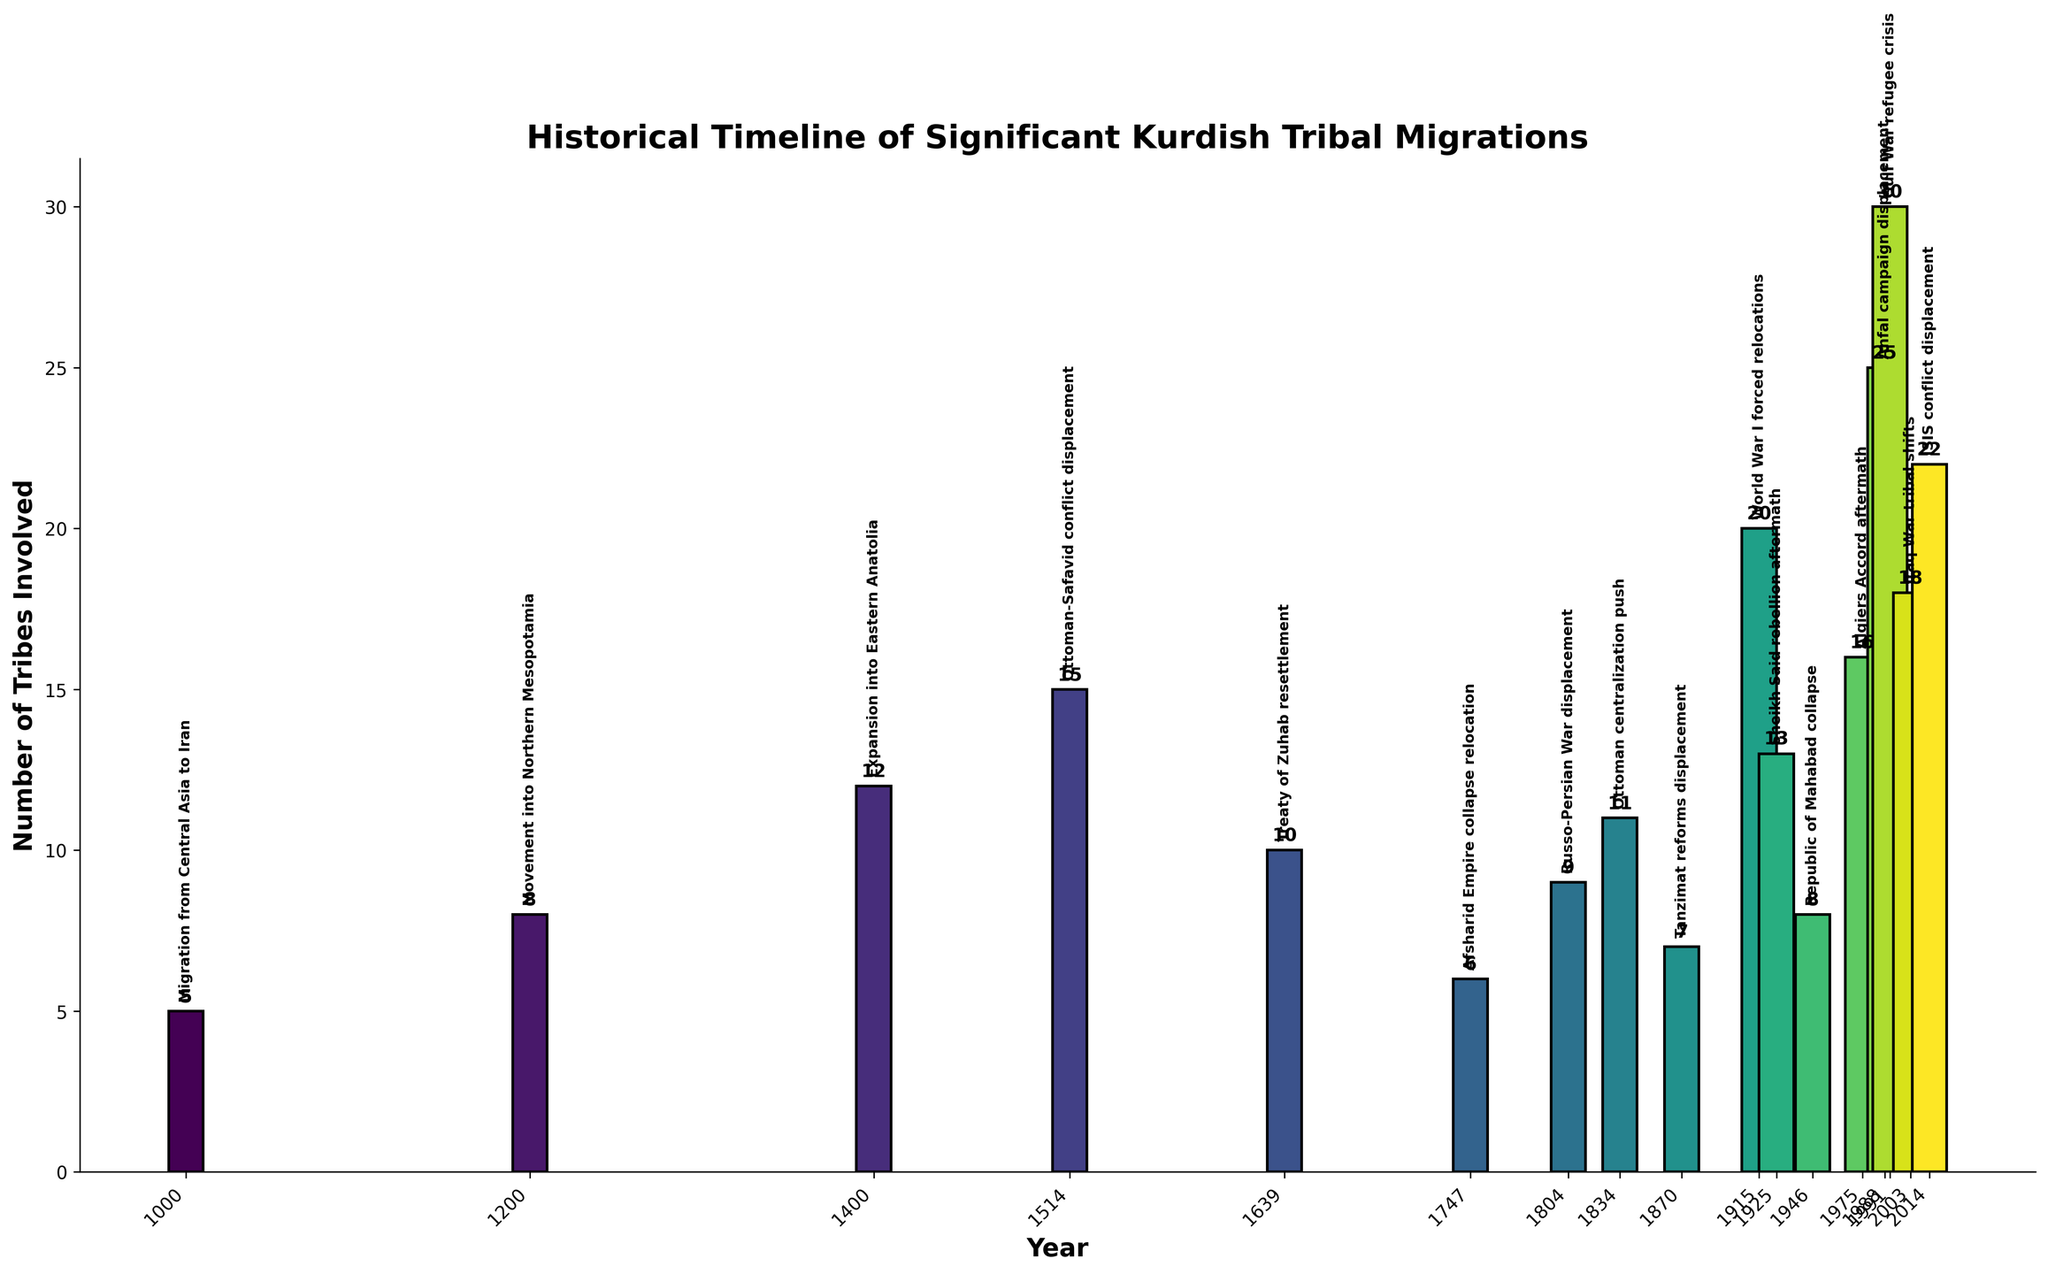Which event involved the largest number of tribes in migration? To answer this, look at the height of the bars and identify the tallest one. The tallest bar represents the "Gulf War refugee crisis" with 30 tribes involved in 1991.
Answer: Gulf War refugee crisis How many migration events involved more than 20 tribes? Identify and count the bars that have a height greater than 20. There are three such events: 1988 Anfal campaign displacement (25 tribes), 1991 Gulf War refugee crisis (30 tribes), and 2014 ISIS conflict displacement (22 tribes).
Answer: 3 What is the difference in the number of tribes involved between the Gulf War refugee crisis and the ISIS conflict displacement? Find the number of tribes involved in both events by checking their respective bars: 1991 (30 tribes) and 2014 (22 tribes). Then subtract the smaller number from the larger one: 30 - 22.
Answer: 8 Which migration event involved the smallest number of tribes? Look for the shortest bar in the visual. The shortest bar is for the "Migration from Central Asia to Iran" in 1000, involving 5 tribes.
Answer: Migration from Central Asia to Iran What is the average number of tribes involved in migration events that occurred before 1500? Add the number of tribes involved in events before 1500: 1000 (5 tribes), 1200 (8 tribes), and 1400 (12 tribes). There are three such events. Compute the average: (5 + 8 + 12) / 3.
Answer: 8.33 How do the number of tribes involved in the Sheikh Said rebellion aftermath compare with the Russo-Persian War displacement? Look at the heights of the bars for 1925 (Sheikh Said rebellion aftermath, 13 tribes) and 1804 (Russo-Persian War displacement, 9 tribes). The Sheikh Said rebellion aftermath involves more tribes (13 > 9).
Answer: More in Sheikh Said rebellion aftermath During which century did the most significant number of migration events take place? Examine the timeline and count the number of events in each century. The highest count occurs in the 20th century (1900s) with five events: 1915, 1925, 1946, 1975, and 1988.
Answer: 20th century How many tribes in total were involved in migrations due to conflicts (e.g., wars, rebellions)? Sum the number of tribes involved in conflict-related migrations: 1514 (15 tribes), 1804 (9 tribes), 1834 (11 tribes), 1915 (20 tribes), 1925 (13 tribes), 1988 (25 tribes), 2003 (18 tribes), 2014 (22 tribes). (15 + 9 + 11 + 20 + 13 + 25 + 18 + 22).
Answer: 133 What is the median number of tribes involved in all migrations? List the numbers of tribes involved in ascending order: 5, 6, 7, 8, 8, 9, 10, 11, 12, 13, 15, 16, 18, 20, 22, 25, 30. The median is the middle value of this ordered list, which is the 9th value.
Answer: 12 Among the migrations caused by treaties, which treaty caused the most displacement? Compare the bars corresponding to the treaty events: the 1639 Treaty of Zuhab resettlement involved 10 tribes. This is the only treaty event, so it caused the most displacement among treaties.
Answer: Treaty of Zuhab 